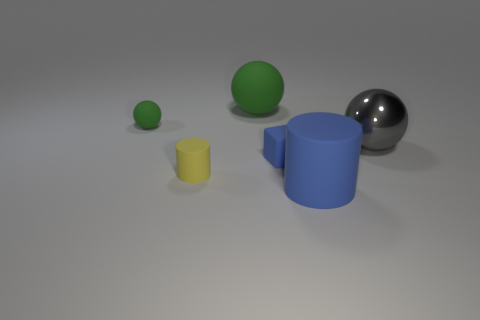What is the size of the metallic object?
Keep it short and to the point. Large. There is a blue object that is the same shape as the yellow matte thing; what is its size?
Your answer should be very brief. Large. There is a metallic thing; what number of large rubber objects are in front of it?
Your answer should be compact. 1. There is a big shiny ball that is in front of the tiny green ball that is behind the yellow thing; what is its color?
Give a very brief answer. Gray. Are there any other things that have the same shape as the big gray metallic thing?
Offer a very short reply. Yes. Are there the same number of gray spheres in front of the big metallic object and large gray metal balls that are behind the yellow rubber object?
Offer a terse response. No. How many blocks are purple objects or blue rubber objects?
Keep it short and to the point. 1. How many other things are there of the same material as the large cylinder?
Make the answer very short. 4. What is the shape of the large rubber thing in front of the small green rubber object?
Ensure brevity in your answer.  Cylinder. What is the material of the green sphere that is right of the rubber cylinder that is behind the big blue matte thing?
Offer a very short reply. Rubber. 